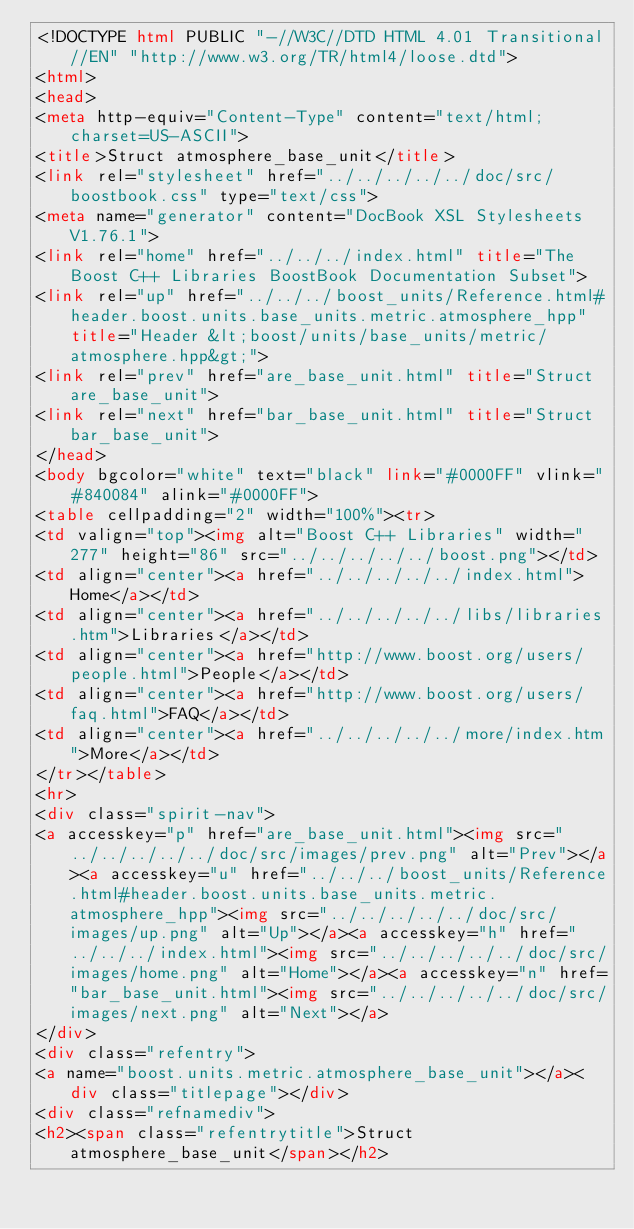<code> <loc_0><loc_0><loc_500><loc_500><_HTML_><!DOCTYPE html PUBLIC "-//W3C//DTD HTML 4.01 Transitional//EN" "http://www.w3.org/TR/html4/loose.dtd">
<html>
<head>
<meta http-equiv="Content-Type" content="text/html; charset=US-ASCII">
<title>Struct atmosphere_base_unit</title>
<link rel="stylesheet" href="../../../../../doc/src/boostbook.css" type="text/css">
<meta name="generator" content="DocBook XSL Stylesheets V1.76.1">
<link rel="home" href="../../../index.html" title="The Boost C++ Libraries BoostBook Documentation Subset">
<link rel="up" href="../../../boost_units/Reference.html#header.boost.units.base_units.metric.atmosphere_hpp" title="Header &lt;boost/units/base_units/metric/atmosphere.hpp&gt;">
<link rel="prev" href="are_base_unit.html" title="Struct are_base_unit">
<link rel="next" href="bar_base_unit.html" title="Struct bar_base_unit">
</head>
<body bgcolor="white" text="black" link="#0000FF" vlink="#840084" alink="#0000FF">
<table cellpadding="2" width="100%"><tr>
<td valign="top"><img alt="Boost C++ Libraries" width="277" height="86" src="../../../../../boost.png"></td>
<td align="center"><a href="../../../../../index.html">Home</a></td>
<td align="center"><a href="../../../../../libs/libraries.htm">Libraries</a></td>
<td align="center"><a href="http://www.boost.org/users/people.html">People</a></td>
<td align="center"><a href="http://www.boost.org/users/faq.html">FAQ</a></td>
<td align="center"><a href="../../../../../more/index.htm">More</a></td>
</tr></table>
<hr>
<div class="spirit-nav">
<a accesskey="p" href="are_base_unit.html"><img src="../../../../../doc/src/images/prev.png" alt="Prev"></a><a accesskey="u" href="../../../boost_units/Reference.html#header.boost.units.base_units.metric.atmosphere_hpp"><img src="../../../../../doc/src/images/up.png" alt="Up"></a><a accesskey="h" href="../../../index.html"><img src="../../../../../doc/src/images/home.png" alt="Home"></a><a accesskey="n" href="bar_base_unit.html"><img src="../../../../../doc/src/images/next.png" alt="Next"></a>
</div>
<div class="refentry">
<a name="boost.units.metric.atmosphere_base_unit"></a><div class="titlepage"></div>
<div class="refnamediv">
<h2><span class="refentrytitle">Struct atmosphere_base_unit</span></h2></code> 